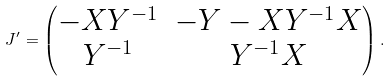Convert formula to latex. <formula><loc_0><loc_0><loc_500><loc_500>J ^ { \prime } = \begin{pmatrix} - X Y ^ { - 1 } & - Y - X Y ^ { - 1 } X \\ Y ^ { - 1 } & Y ^ { - 1 } X \end{pmatrix} .</formula> 